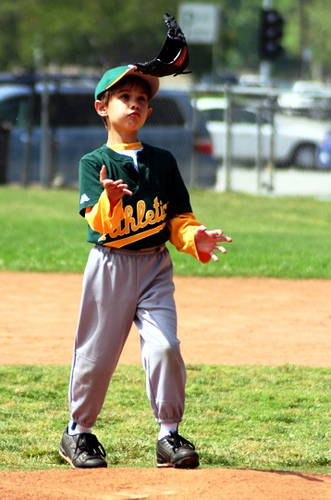<image>
Can you confirm if the child is on the dirt path? Yes. Looking at the image, I can see the child is positioned on top of the dirt path, with the dirt path providing support. Is there a glove on the ground? No. The glove is not positioned on the ground. They may be near each other, but the glove is not supported by or resting on top of the ground. Is the glove in the child? No. The glove is not contained within the child. These objects have a different spatial relationship. 